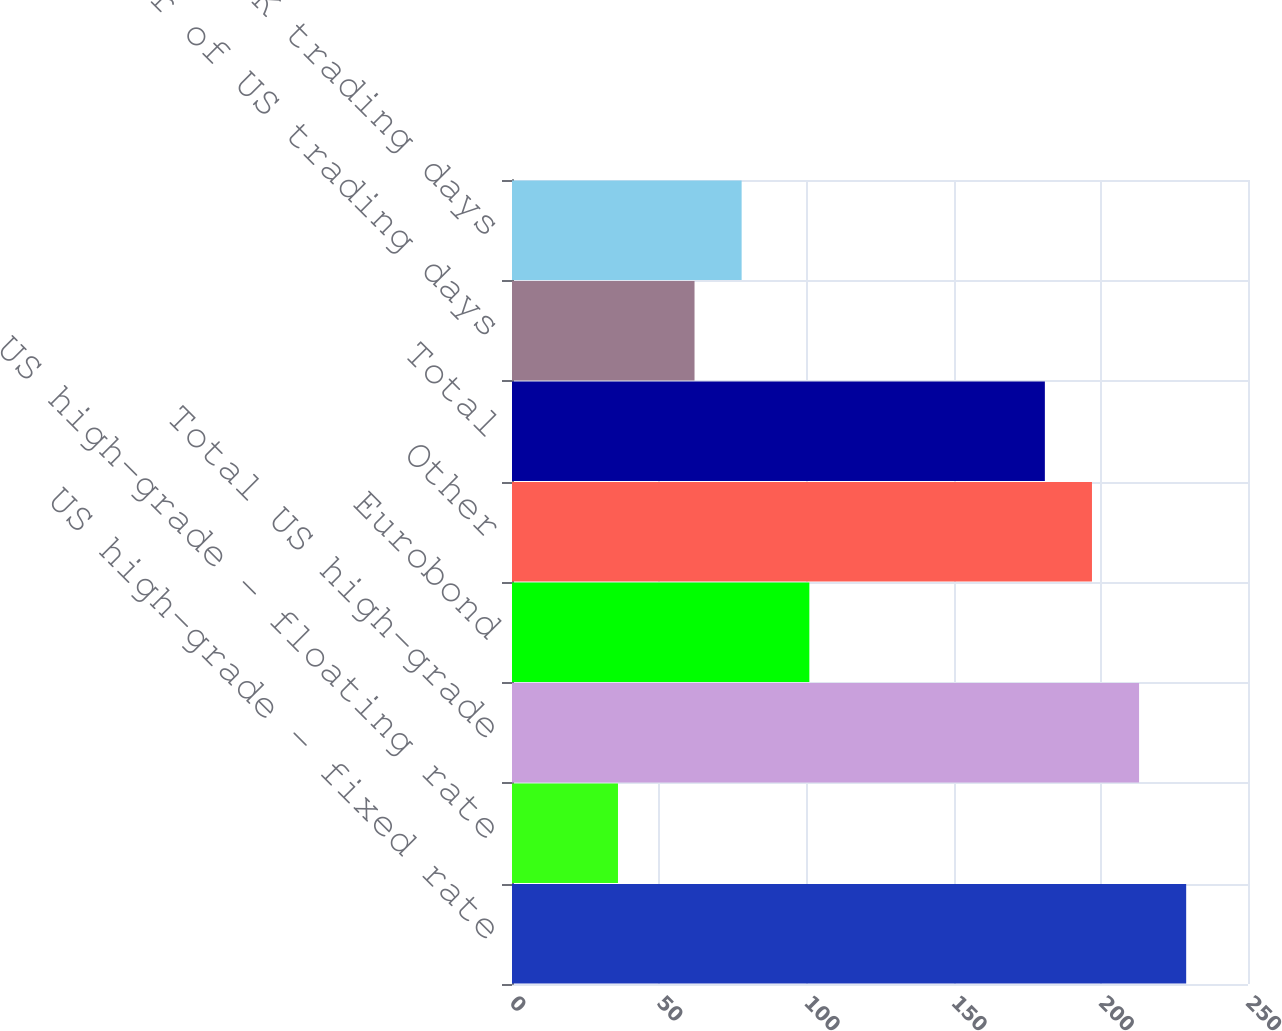<chart> <loc_0><loc_0><loc_500><loc_500><bar_chart><fcel>US high-grade - fixed rate<fcel>US high-grade - floating rate<fcel>Total US high-grade<fcel>Eurobond<fcel>Other<fcel>Total<fcel>Number of US trading days<fcel>Number of UK trading days<nl><fcel>229<fcel>36<fcel>213<fcel>101<fcel>197<fcel>181<fcel>62<fcel>78<nl></chart> 